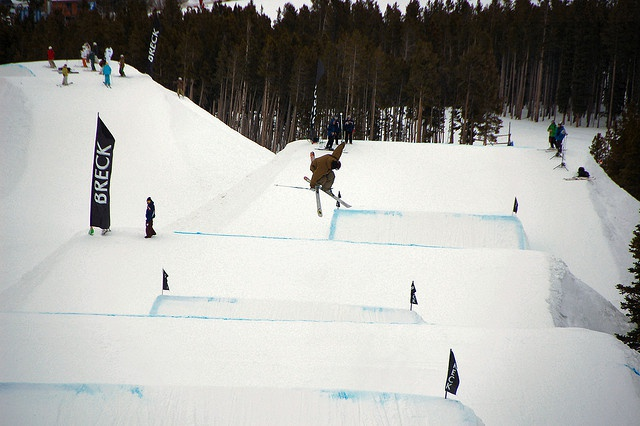Describe the objects in this image and their specific colors. I can see people in black, maroon, and gray tones, people in black, lightgray, darkgray, and gray tones, skis in black, darkgray, white, and gray tones, people in black, gray, navy, and purple tones, and people in black, navy, gray, and darkgray tones in this image. 